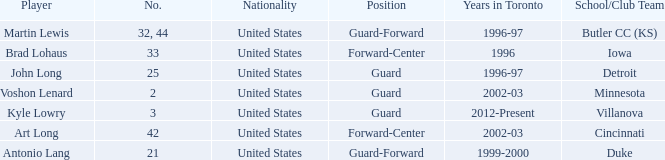What school did player number 21 play for? Duke. 